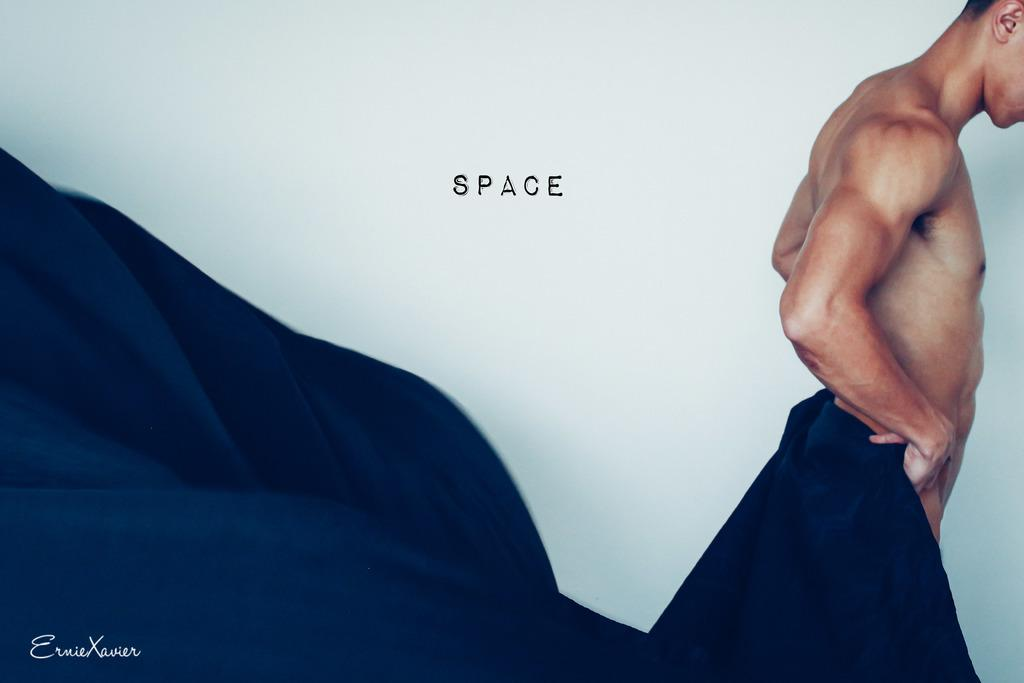What is the main subject of the image? The main subject of the image is a photograph of a man. What is the man in the image not wearing? The man is not wearing clothes. What is the man holding in the image? The man is holding a blue cloth near his hip. What type of haircut does the man have in the image? There is no information about the man's haircut in the image. What kind of vessel is the man using to hold the blue cloth? There is no vessel present in the image; the man is simply holding the blue cloth with his hand. 